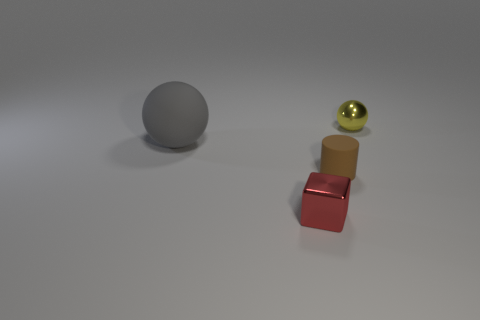Add 1 purple spheres. How many objects exist? 5 Subtract all cubes. How many objects are left? 3 Subtract all purple balls. Subtract all gray cylinders. How many balls are left? 2 Subtract all purple cylinders. How many blue cubes are left? 0 Subtract all large gray cylinders. Subtract all tiny red shiny blocks. How many objects are left? 3 Add 4 yellow shiny objects. How many yellow shiny objects are left? 5 Add 3 brown matte cylinders. How many brown matte cylinders exist? 4 Subtract 0 yellow cylinders. How many objects are left? 4 Subtract 2 balls. How many balls are left? 0 